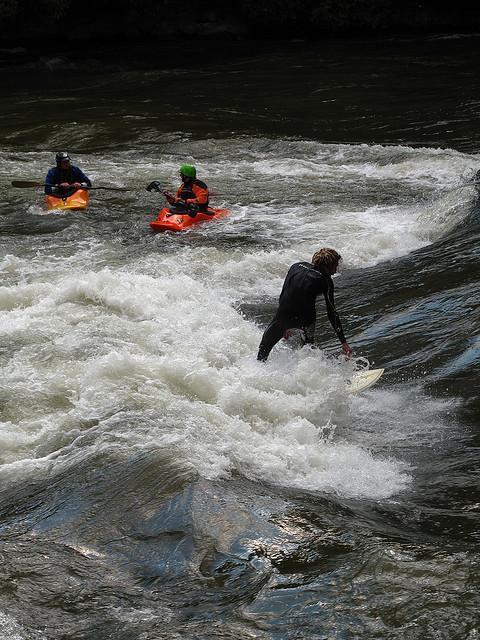How many people are sitting in kayaks?
Give a very brief answer. 2. How many people are in the photo?
Give a very brief answer. 1. How many cows are there?
Give a very brief answer. 0. 